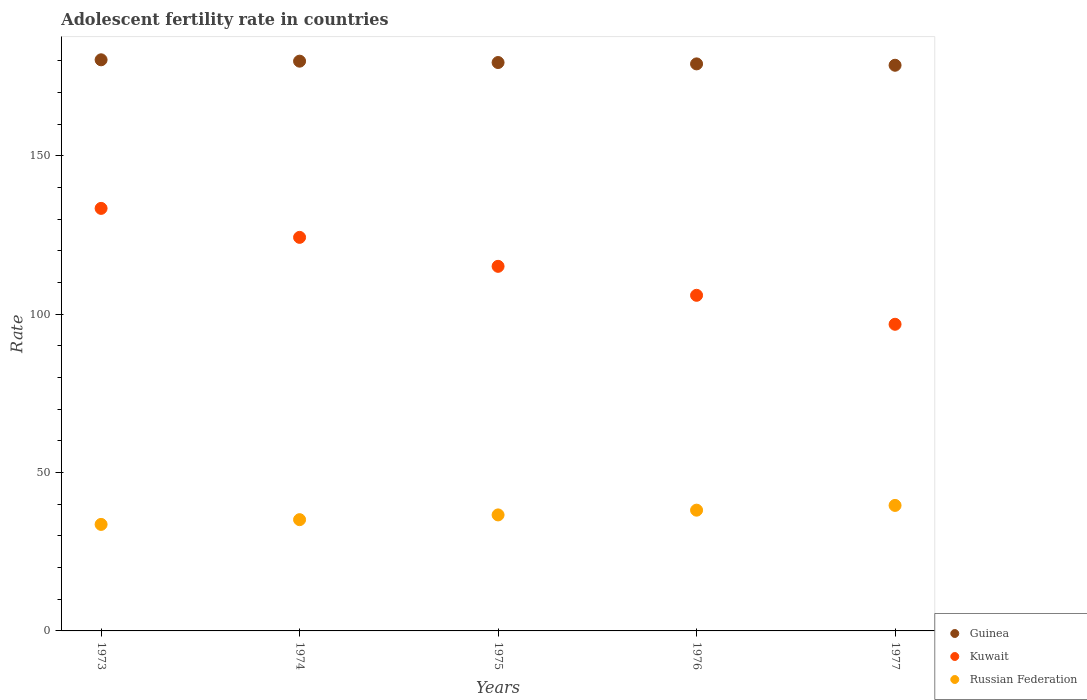What is the adolescent fertility rate in Kuwait in 1974?
Provide a succinct answer. 124.25. Across all years, what is the maximum adolescent fertility rate in Russian Federation?
Your answer should be very brief. 39.62. Across all years, what is the minimum adolescent fertility rate in Guinea?
Ensure brevity in your answer.  178.59. What is the total adolescent fertility rate in Russian Federation in the graph?
Provide a succinct answer. 183.12. What is the difference between the adolescent fertility rate in Guinea in 1973 and that in 1976?
Offer a very short reply. 1.29. What is the difference between the adolescent fertility rate in Russian Federation in 1975 and the adolescent fertility rate in Kuwait in 1977?
Provide a short and direct response. -60.18. What is the average adolescent fertility rate in Russian Federation per year?
Your answer should be compact. 36.62. In the year 1977, what is the difference between the adolescent fertility rate in Russian Federation and adolescent fertility rate in Kuwait?
Make the answer very short. -57.19. In how many years, is the adolescent fertility rate in Russian Federation greater than 40?
Give a very brief answer. 0. What is the ratio of the adolescent fertility rate in Russian Federation in 1973 to that in 1977?
Offer a terse response. 0.85. Is the adolescent fertility rate in Guinea in 1976 less than that in 1977?
Give a very brief answer. No. Is the difference between the adolescent fertility rate in Russian Federation in 1975 and 1977 greater than the difference between the adolescent fertility rate in Kuwait in 1975 and 1977?
Make the answer very short. No. What is the difference between the highest and the second highest adolescent fertility rate in Guinea?
Your response must be concise. 0.43. What is the difference between the highest and the lowest adolescent fertility rate in Kuwait?
Make the answer very short. 36.59. In how many years, is the adolescent fertility rate in Guinea greater than the average adolescent fertility rate in Guinea taken over all years?
Your answer should be very brief. 2. Is the sum of the adolescent fertility rate in Guinea in 1975 and 1977 greater than the maximum adolescent fertility rate in Russian Federation across all years?
Your answer should be compact. Yes. Is it the case that in every year, the sum of the adolescent fertility rate in Kuwait and adolescent fertility rate in Guinea  is greater than the adolescent fertility rate in Russian Federation?
Offer a terse response. Yes. Does the adolescent fertility rate in Kuwait monotonically increase over the years?
Make the answer very short. No. How many dotlines are there?
Provide a short and direct response. 3. What is the difference between two consecutive major ticks on the Y-axis?
Offer a terse response. 50. Does the graph contain any zero values?
Ensure brevity in your answer.  No. Where does the legend appear in the graph?
Offer a very short reply. Bottom right. How many legend labels are there?
Ensure brevity in your answer.  3. How are the legend labels stacked?
Ensure brevity in your answer.  Vertical. What is the title of the graph?
Offer a terse response. Adolescent fertility rate in countries. What is the label or title of the Y-axis?
Provide a succinct answer. Rate. What is the Rate of Guinea in 1973?
Your response must be concise. 180.3. What is the Rate of Kuwait in 1973?
Offer a terse response. 133.4. What is the Rate of Russian Federation in 1973?
Give a very brief answer. 33.63. What is the Rate of Guinea in 1974?
Give a very brief answer. 179.87. What is the Rate of Kuwait in 1974?
Make the answer very short. 124.25. What is the Rate in Russian Federation in 1974?
Give a very brief answer. 35.12. What is the Rate of Guinea in 1975?
Your answer should be compact. 179.44. What is the Rate in Kuwait in 1975?
Offer a terse response. 115.1. What is the Rate in Russian Federation in 1975?
Offer a terse response. 36.62. What is the Rate in Guinea in 1976?
Your response must be concise. 179.01. What is the Rate of Kuwait in 1976?
Your response must be concise. 105.95. What is the Rate of Russian Federation in 1976?
Offer a very short reply. 38.12. What is the Rate in Guinea in 1977?
Provide a short and direct response. 178.59. What is the Rate in Kuwait in 1977?
Your response must be concise. 96.81. What is the Rate in Russian Federation in 1977?
Your response must be concise. 39.62. Across all years, what is the maximum Rate of Guinea?
Offer a terse response. 180.3. Across all years, what is the maximum Rate in Kuwait?
Provide a succinct answer. 133.4. Across all years, what is the maximum Rate of Russian Federation?
Provide a short and direct response. 39.62. Across all years, what is the minimum Rate in Guinea?
Your answer should be very brief. 178.59. Across all years, what is the minimum Rate in Kuwait?
Provide a short and direct response. 96.81. Across all years, what is the minimum Rate of Russian Federation?
Provide a short and direct response. 33.63. What is the total Rate in Guinea in the graph?
Make the answer very short. 897.22. What is the total Rate in Kuwait in the graph?
Keep it short and to the point. 575.51. What is the total Rate in Russian Federation in the graph?
Keep it short and to the point. 183.12. What is the difference between the Rate of Guinea in 1973 and that in 1974?
Provide a succinct answer. 0.43. What is the difference between the Rate in Kuwait in 1973 and that in 1974?
Your answer should be compact. 9.15. What is the difference between the Rate in Russian Federation in 1973 and that in 1974?
Offer a terse response. -1.5. What is the difference between the Rate in Guinea in 1973 and that in 1975?
Ensure brevity in your answer.  0.86. What is the difference between the Rate in Kuwait in 1973 and that in 1975?
Ensure brevity in your answer.  18.29. What is the difference between the Rate of Russian Federation in 1973 and that in 1975?
Provide a short and direct response. -3. What is the difference between the Rate of Guinea in 1973 and that in 1976?
Your answer should be compact. 1.29. What is the difference between the Rate in Kuwait in 1973 and that in 1976?
Provide a short and direct response. 27.44. What is the difference between the Rate in Russian Federation in 1973 and that in 1976?
Ensure brevity in your answer.  -4.5. What is the difference between the Rate of Guinea in 1973 and that in 1977?
Your response must be concise. 1.72. What is the difference between the Rate of Kuwait in 1973 and that in 1977?
Your answer should be very brief. 36.59. What is the difference between the Rate in Russian Federation in 1973 and that in 1977?
Offer a terse response. -6. What is the difference between the Rate of Guinea in 1974 and that in 1975?
Ensure brevity in your answer.  0.43. What is the difference between the Rate in Kuwait in 1974 and that in 1975?
Make the answer very short. 9.15. What is the difference between the Rate of Russian Federation in 1974 and that in 1975?
Provide a short and direct response. -1.5. What is the difference between the Rate of Guinea in 1974 and that in 1976?
Your response must be concise. 0.86. What is the difference between the Rate in Kuwait in 1974 and that in 1976?
Your answer should be very brief. 18.29. What is the difference between the Rate of Russian Federation in 1974 and that in 1976?
Keep it short and to the point. -3. What is the difference between the Rate in Guinea in 1974 and that in 1977?
Offer a very short reply. 1.29. What is the difference between the Rate of Kuwait in 1974 and that in 1977?
Your response must be concise. 27.44. What is the difference between the Rate in Russian Federation in 1974 and that in 1977?
Provide a succinct answer. -4.5. What is the difference between the Rate in Guinea in 1975 and that in 1976?
Your answer should be very brief. 0.43. What is the difference between the Rate of Kuwait in 1975 and that in 1976?
Ensure brevity in your answer.  9.15. What is the difference between the Rate of Russian Federation in 1975 and that in 1976?
Ensure brevity in your answer.  -1.5. What is the difference between the Rate of Guinea in 1975 and that in 1977?
Provide a short and direct response. 0.86. What is the difference between the Rate of Kuwait in 1975 and that in 1977?
Make the answer very short. 18.29. What is the difference between the Rate in Russian Federation in 1975 and that in 1977?
Give a very brief answer. -3. What is the difference between the Rate in Guinea in 1976 and that in 1977?
Keep it short and to the point. 0.43. What is the difference between the Rate of Kuwait in 1976 and that in 1977?
Provide a succinct answer. 9.15. What is the difference between the Rate of Russian Federation in 1976 and that in 1977?
Keep it short and to the point. -1.5. What is the difference between the Rate in Guinea in 1973 and the Rate in Kuwait in 1974?
Your answer should be compact. 56.06. What is the difference between the Rate of Guinea in 1973 and the Rate of Russian Federation in 1974?
Offer a terse response. 145.18. What is the difference between the Rate in Kuwait in 1973 and the Rate in Russian Federation in 1974?
Your response must be concise. 98.27. What is the difference between the Rate of Guinea in 1973 and the Rate of Kuwait in 1975?
Your answer should be compact. 65.2. What is the difference between the Rate in Guinea in 1973 and the Rate in Russian Federation in 1975?
Your response must be concise. 143.68. What is the difference between the Rate in Kuwait in 1973 and the Rate in Russian Federation in 1975?
Give a very brief answer. 96.77. What is the difference between the Rate of Guinea in 1973 and the Rate of Kuwait in 1976?
Provide a short and direct response. 74.35. What is the difference between the Rate of Guinea in 1973 and the Rate of Russian Federation in 1976?
Ensure brevity in your answer.  142.18. What is the difference between the Rate in Kuwait in 1973 and the Rate in Russian Federation in 1976?
Provide a succinct answer. 95.27. What is the difference between the Rate in Guinea in 1973 and the Rate in Kuwait in 1977?
Your answer should be very brief. 83.5. What is the difference between the Rate of Guinea in 1973 and the Rate of Russian Federation in 1977?
Give a very brief answer. 140.68. What is the difference between the Rate of Kuwait in 1973 and the Rate of Russian Federation in 1977?
Your answer should be very brief. 93.77. What is the difference between the Rate in Guinea in 1974 and the Rate in Kuwait in 1975?
Make the answer very short. 64.77. What is the difference between the Rate of Guinea in 1974 and the Rate of Russian Federation in 1975?
Your answer should be compact. 143.25. What is the difference between the Rate of Kuwait in 1974 and the Rate of Russian Federation in 1975?
Your answer should be very brief. 87.62. What is the difference between the Rate of Guinea in 1974 and the Rate of Kuwait in 1976?
Keep it short and to the point. 73.92. What is the difference between the Rate in Guinea in 1974 and the Rate in Russian Federation in 1976?
Make the answer very short. 141.75. What is the difference between the Rate in Kuwait in 1974 and the Rate in Russian Federation in 1976?
Your answer should be very brief. 86.13. What is the difference between the Rate in Guinea in 1974 and the Rate in Kuwait in 1977?
Provide a succinct answer. 83.07. What is the difference between the Rate in Guinea in 1974 and the Rate in Russian Federation in 1977?
Your response must be concise. 140.25. What is the difference between the Rate of Kuwait in 1974 and the Rate of Russian Federation in 1977?
Give a very brief answer. 84.63. What is the difference between the Rate of Guinea in 1975 and the Rate of Kuwait in 1976?
Offer a very short reply. 73.49. What is the difference between the Rate of Guinea in 1975 and the Rate of Russian Federation in 1976?
Your answer should be very brief. 141.32. What is the difference between the Rate of Kuwait in 1975 and the Rate of Russian Federation in 1976?
Keep it short and to the point. 76.98. What is the difference between the Rate in Guinea in 1975 and the Rate in Kuwait in 1977?
Provide a succinct answer. 82.64. What is the difference between the Rate of Guinea in 1975 and the Rate of Russian Federation in 1977?
Offer a very short reply. 139.82. What is the difference between the Rate in Kuwait in 1975 and the Rate in Russian Federation in 1977?
Provide a succinct answer. 75.48. What is the difference between the Rate in Guinea in 1976 and the Rate in Kuwait in 1977?
Your answer should be compact. 82.21. What is the difference between the Rate of Guinea in 1976 and the Rate of Russian Federation in 1977?
Provide a short and direct response. 139.39. What is the difference between the Rate in Kuwait in 1976 and the Rate in Russian Federation in 1977?
Your answer should be very brief. 66.33. What is the average Rate of Guinea per year?
Your response must be concise. 179.44. What is the average Rate in Kuwait per year?
Give a very brief answer. 115.1. What is the average Rate of Russian Federation per year?
Provide a succinct answer. 36.62. In the year 1973, what is the difference between the Rate of Guinea and Rate of Kuwait?
Your answer should be compact. 46.91. In the year 1973, what is the difference between the Rate in Guinea and Rate in Russian Federation?
Keep it short and to the point. 146.68. In the year 1973, what is the difference between the Rate of Kuwait and Rate of Russian Federation?
Your answer should be very brief. 99.77. In the year 1974, what is the difference between the Rate in Guinea and Rate in Kuwait?
Provide a short and direct response. 55.63. In the year 1974, what is the difference between the Rate in Guinea and Rate in Russian Federation?
Provide a short and direct response. 144.75. In the year 1974, what is the difference between the Rate of Kuwait and Rate of Russian Federation?
Provide a short and direct response. 89.12. In the year 1975, what is the difference between the Rate in Guinea and Rate in Kuwait?
Keep it short and to the point. 64.34. In the year 1975, what is the difference between the Rate of Guinea and Rate of Russian Federation?
Provide a succinct answer. 142.82. In the year 1975, what is the difference between the Rate in Kuwait and Rate in Russian Federation?
Give a very brief answer. 78.48. In the year 1976, what is the difference between the Rate of Guinea and Rate of Kuwait?
Give a very brief answer. 73.06. In the year 1976, what is the difference between the Rate in Guinea and Rate in Russian Federation?
Ensure brevity in your answer.  140.89. In the year 1976, what is the difference between the Rate of Kuwait and Rate of Russian Federation?
Your answer should be very brief. 67.83. In the year 1977, what is the difference between the Rate in Guinea and Rate in Kuwait?
Keep it short and to the point. 81.78. In the year 1977, what is the difference between the Rate of Guinea and Rate of Russian Federation?
Your answer should be very brief. 138.96. In the year 1977, what is the difference between the Rate of Kuwait and Rate of Russian Federation?
Offer a very short reply. 57.19. What is the ratio of the Rate in Guinea in 1973 to that in 1974?
Provide a short and direct response. 1. What is the ratio of the Rate of Kuwait in 1973 to that in 1974?
Offer a terse response. 1.07. What is the ratio of the Rate of Russian Federation in 1973 to that in 1974?
Ensure brevity in your answer.  0.96. What is the ratio of the Rate of Guinea in 1973 to that in 1975?
Provide a succinct answer. 1. What is the ratio of the Rate in Kuwait in 1973 to that in 1975?
Ensure brevity in your answer.  1.16. What is the ratio of the Rate of Russian Federation in 1973 to that in 1975?
Your response must be concise. 0.92. What is the ratio of the Rate in Kuwait in 1973 to that in 1976?
Keep it short and to the point. 1.26. What is the ratio of the Rate of Russian Federation in 1973 to that in 1976?
Give a very brief answer. 0.88. What is the ratio of the Rate of Guinea in 1973 to that in 1977?
Your response must be concise. 1.01. What is the ratio of the Rate of Kuwait in 1973 to that in 1977?
Offer a very short reply. 1.38. What is the ratio of the Rate of Russian Federation in 1973 to that in 1977?
Make the answer very short. 0.85. What is the ratio of the Rate in Kuwait in 1974 to that in 1975?
Provide a short and direct response. 1.08. What is the ratio of the Rate of Russian Federation in 1974 to that in 1975?
Give a very brief answer. 0.96. What is the ratio of the Rate of Guinea in 1974 to that in 1976?
Your response must be concise. 1. What is the ratio of the Rate in Kuwait in 1974 to that in 1976?
Your answer should be compact. 1.17. What is the ratio of the Rate of Russian Federation in 1974 to that in 1976?
Provide a succinct answer. 0.92. What is the ratio of the Rate of Guinea in 1974 to that in 1977?
Make the answer very short. 1.01. What is the ratio of the Rate of Kuwait in 1974 to that in 1977?
Provide a short and direct response. 1.28. What is the ratio of the Rate in Russian Federation in 1974 to that in 1977?
Provide a short and direct response. 0.89. What is the ratio of the Rate in Kuwait in 1975 to that in 1976?
Provide a short and direct response. 1.09. What is the ratio of the Rate in Russian Federation in 1975 to that in 1976?
Provide a succinct answer. 0.96. What is the ratio of the Rate in Guinea in 1975 to that in 1977?
Your answer should be compact. 1. What is the ratio of the Rate in Kuwait in 1975 to that in 1977?
Provide a short and direct response. 1.19. What is the ratio of the Rate of Russian Federation in 1975 to that in 1977?
Provide a succinct answer. 0.92. What is the ratio of the Rate of Guinea in 1976 to that in 1977?
Provide a short and direct response. 1. What is the ratio of the Rate in Kuwait in 1976 to that in 1977?
Your response must be concise. 1.09. What is the ratio of the Rate of Russian Federation in 1976 to that in 1977?
Offer a very short reply. 0.96. What is the difference between the highest and the second highest Rate of Guinea?
Provide a succinct answer. 0.43. What is the difference between the highest and the second highest Rate in Kuwait?
Offer a terse response. 9.15. What is the difference between the highest and the second highest Rate in Russian Federation?
Provide a short and direct response. 1.5. What is the difference between the highest and the lowest Rate of Guinea?
Give a very brief answer. 1.72. What is the difference between the highest and the lowest Rate in Kuwait?
Ensure brevity in your answer.  36.59. What is the difference between the highest and the lowest Rate in Russian Federation?
Your response must be concise. 6. 